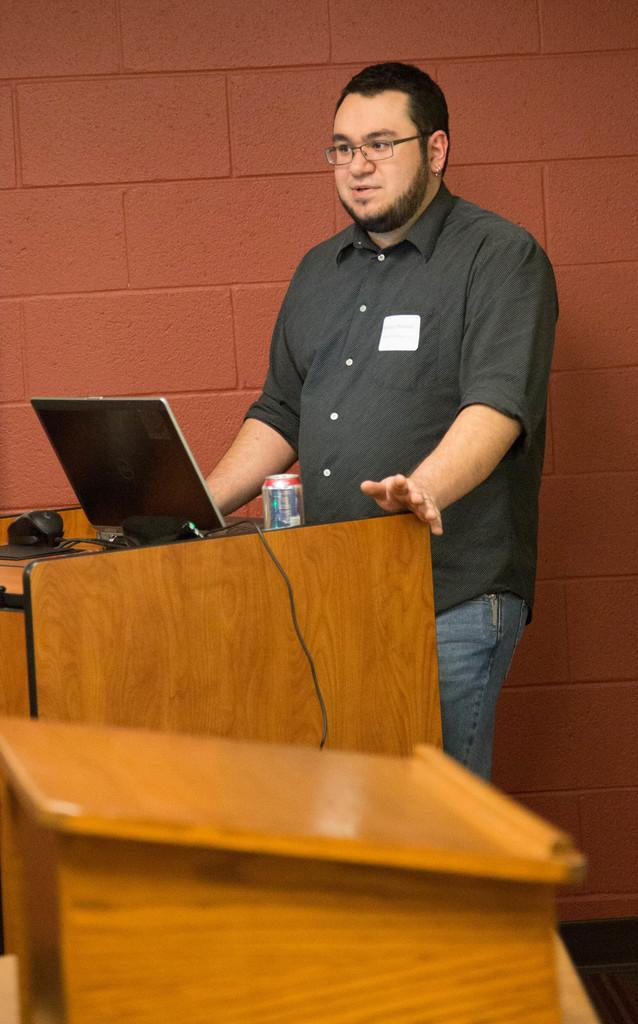Who is present in the image? There is a guy in the image. What is the guy standing in front of? The guy is standing in front of a brown color table. What object is on top of the table? There is a laptop on top of the table. What color is the wall in the background? The wall in the background is red in color. What type of sack is the guy holding in the image? There is no sack present in the image. Is the guy playing a guitar in the image? There is no guitar present in the image. 